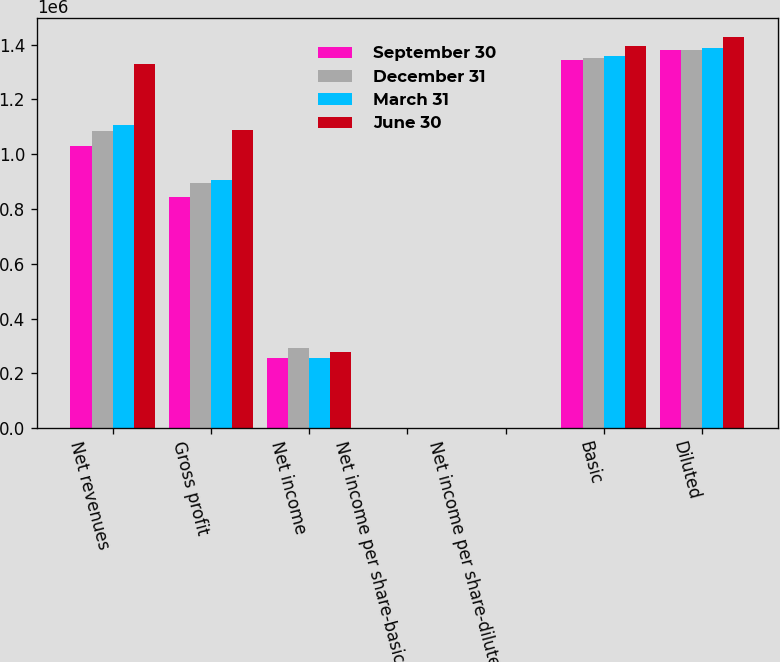<chart> <loc_0><loc_0><loc_500><loc_500><stacked_bar_chart><ecel><fcel>Net revenues<fcel>Gross profit<fcel>Net income<fcel>Net income per share-basic<fcel>Net income per share-diluted<fcel>Basic<fcel>Diluted<nl><fcel>September 30<fcel>1.03172e+06<fcel>845355<fcel>256291<fcel>0.19<fcel>0.19<fcel>1.34344e+06<fcel>1.38215e+06<nl><fcel>December 31<fcel>1.0863e+06<fcel>894463<fcel>291560<fcel>0.22<fcel>0.21<fcel>1.35138e+06<fcel>1.37909e+06<nl><fcel>March 31<fcel>1.10552e+06<fcel>905140<fcel>254971<fcel>0.19<fcel>0.18<fcel>1.35724e+06<fcel>1.38704e+06<nl><fcel>June 30<fcel>1.32886e+06<fcel>1.08934e+06<fcel>279221<fcel>0.2<fcel>0.2<fcel>1.39457e+06<fcel>1.42648e+06<nl></chart> 